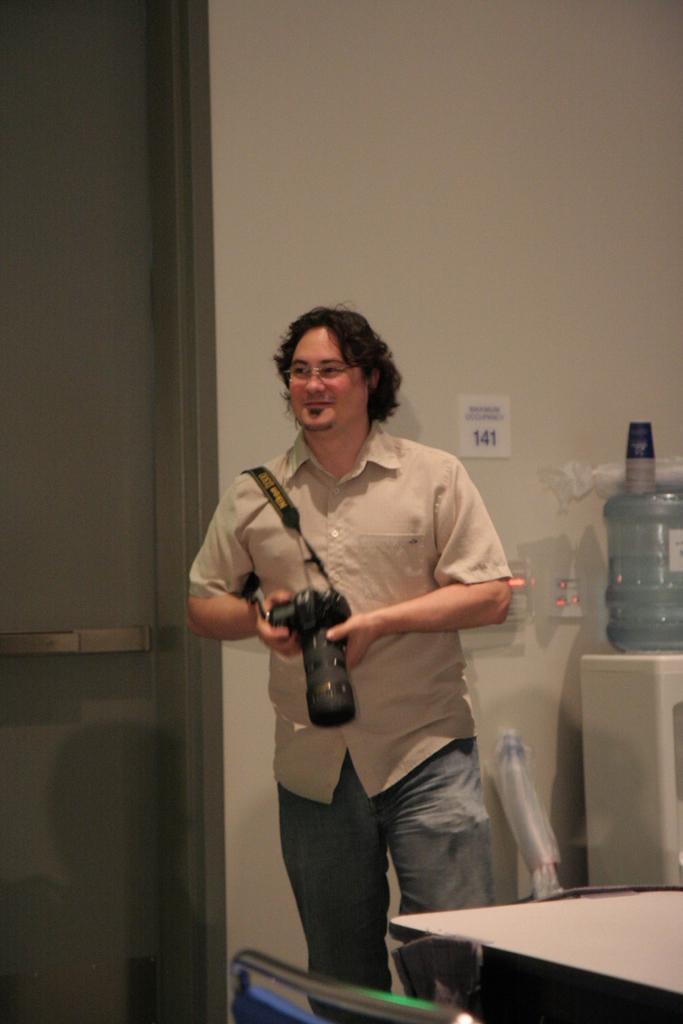Describe this image in one or two sentences. In this picture we can see a person holding a camera in his hand and smiling. There is a chair and a table on the right side. We can see a water storage can and a few cups on it. There is a number on the wall. 